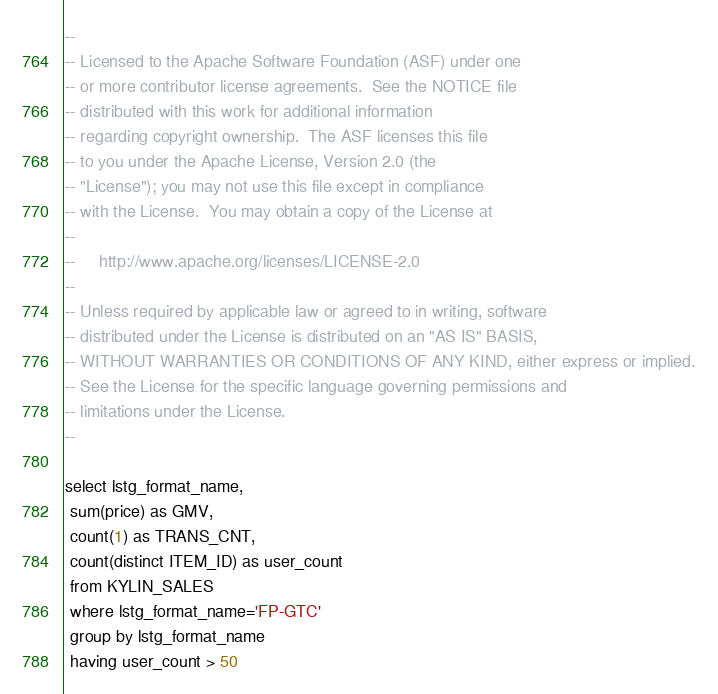<code> <loc_0><loc_0><loc_500><loc_500><_SQL_>--
-- Licensed to the Apache Software Foundation (ASF) under one
-- or more contributor license agreements.  See the NOTICE file
-- distributed with this work for additional information
-- regarding copyright ownership.  The ASF licenses this file
-- to you under the Apache License, Version 2.0 (the
-- "License"); you may not use this file except in compliance
-- with the License.  You may obtain a copy of the License at
--
--     http://www.apache.org/licenses/LICENSE-2.0
--
-- Unless required by applicable law or agreed to in writing, software
-- distributed under the License is distributed on an "AS IS" BASIS,
-- WITHOUT WARRANTIES OR CONDITIONS OF ANY KIND, either express or implied.
-- See the License for the specific language governing permissions and
-- limitations under the License.
--

select lstg_format_name,
 sum(price) as GMV,
 count(1) as TRANS_CNT,
 count(distinct ITEM_ID) as user_count
 from KYLIN_SALES
 where lstg_format_name='FP-GTC'
 group by lstg_format_name
 having user_count > 50</code> 